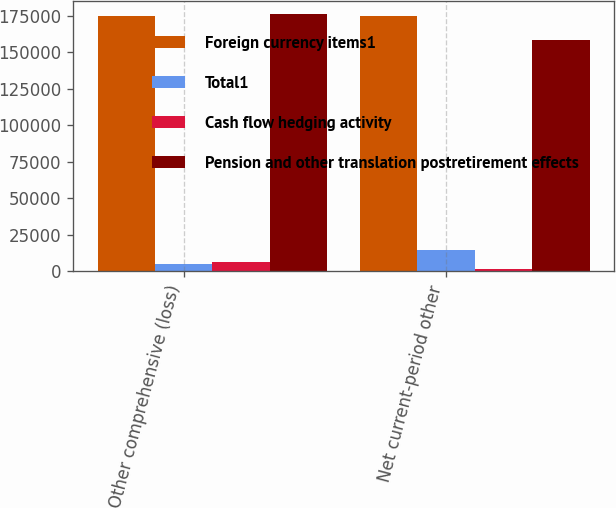Convert chart. <chart><loc_0><loc_0><loc_500><loc_500><stacked_bar_chart><ecel><fcel>Other comprehensive (loss)<fcel>Net current-period other<nl><fcel>Foreign currency items1<fcel>174889<fcel>174889<nl><fcel>Total1<fcel>4977<fcel>14937<nl><fcel>Cash flow hedging activity<fcel>6382<fcel>1752<nl><fcel>Pension and other translation postretirement effects<fcel>176294<fcel>158200<nl></chart> 